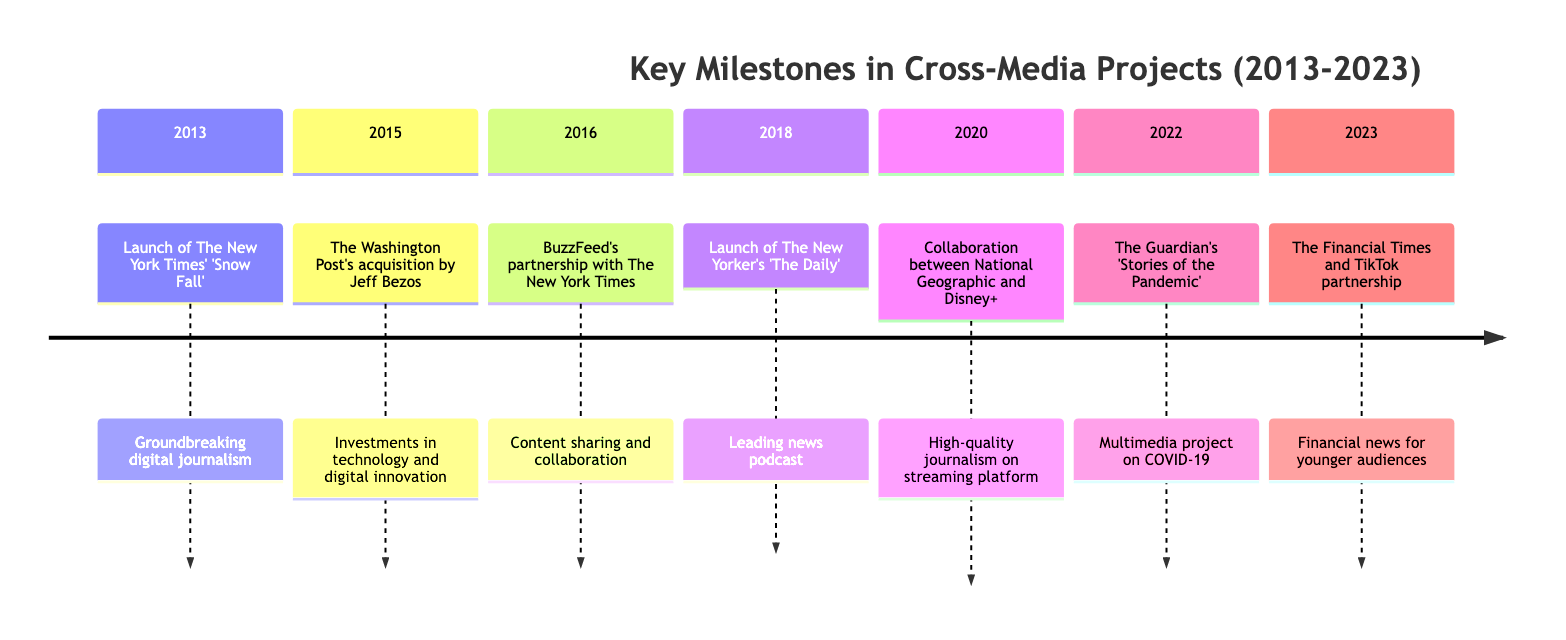What was the first milestone in the timeline? The first milestone noted in the timeline is from 2013, which is the launch of The New York Times' 'Snow Fall'.
Answer: Launch of The New York Times' 'Snow Fall' How many milestones are listed in this timeline? There are seven milestones represented in the timeline, as indicated by the seven distinct entries for each year from 2013 to 2023.
Answer: 7 What year did The Washington Post's acquisition by Jeff Bezos occur? The acquisition of The Washington Post by Jeff Bezos occurred in 2015, as that is the date associated with this milestone in the timeline.
Answer: 2015 Which organization launched 'The Daily' in 2018? 'The Daily' was launched by The New Yorker in 2018, as stated in the corresponding entry of the timeline.
Answer: The New Yorker What type of project is 'Stories of the Pandemic' by The Guardian? 'Stories of the Pandemic' is described as a multimedia project that combines written articles, videos, and interactive graphics, showcasing cross-media collaboration.
Answer: Multimedia project Describe the nature of collaboration between National Geographic and Disney+ in 2020. The collaboration involves National Geographic launching several series on Disney+, which combines high-quality print journalism with visual storytelling on a streaming platform.
Answer: Series launch Which two organizations partnered in 2023 to create content for TikTok? In 2023, The Financial Times partnered with TikTok to produce financial news content aimed at younger audiences.
Answer: The Financial Times and TikTok What significant change occurred after Jeff Bezos acquired The Washington Post? The significant change involved substantial investments in technology and digital innovation, revitalizing the newspaper's approach to cross-media projects.
Answer: Investments in technology and digital innovation Which milestone represents a successful integration of traditional journalism and modern digital media strategies? The partnership between BuzzFeed and The New York Times in 2016 represents a successful integration of traditional journalism with modern digital media strategies through a content-sharing agreement.
Answer: BuzzFeed's partnership with The New York Times 